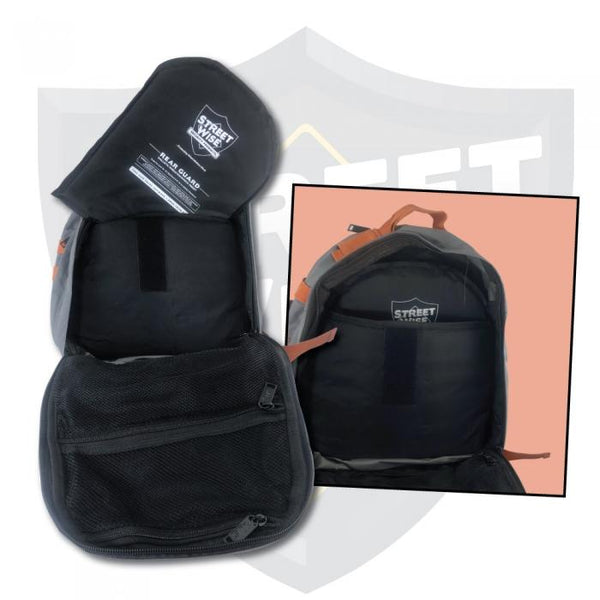Considering the design features visible on the backpack in the foreground, what specific use or user might this backpack be intended for, and why would those features be beneficial? The backpack in the foreground appears to be designed with several features that suggest it is tailored for cyclists or motorcyclists. These users often need enhanced visibility and ventilation during their rides. The backpack's tapered upper section is likely designed to accommodate a helmet, addressing a common need for these types of users. Additionally, the 'enhanced visibility' label hints at safety features such as reflective elements, which are critical for being seen by other road users, particularly in low-light conditions. The ventilated mesh compartment is ideal for storing items that require air circulation, such as wet clothing or protective gear, ensuring they dry more quickly and stay fresh. These features collectively make the backpack highly functional for individuals who are frequently on the move and need practical storage solutions. 